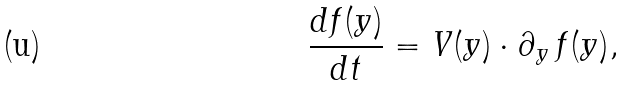<formula> <loc_0><loc_0><loc_500><loc_500>\frac { d f ( y ) } { d t } = V ( y ) \cdot \partial _ { y } \, f ( y ) ,</formula> 